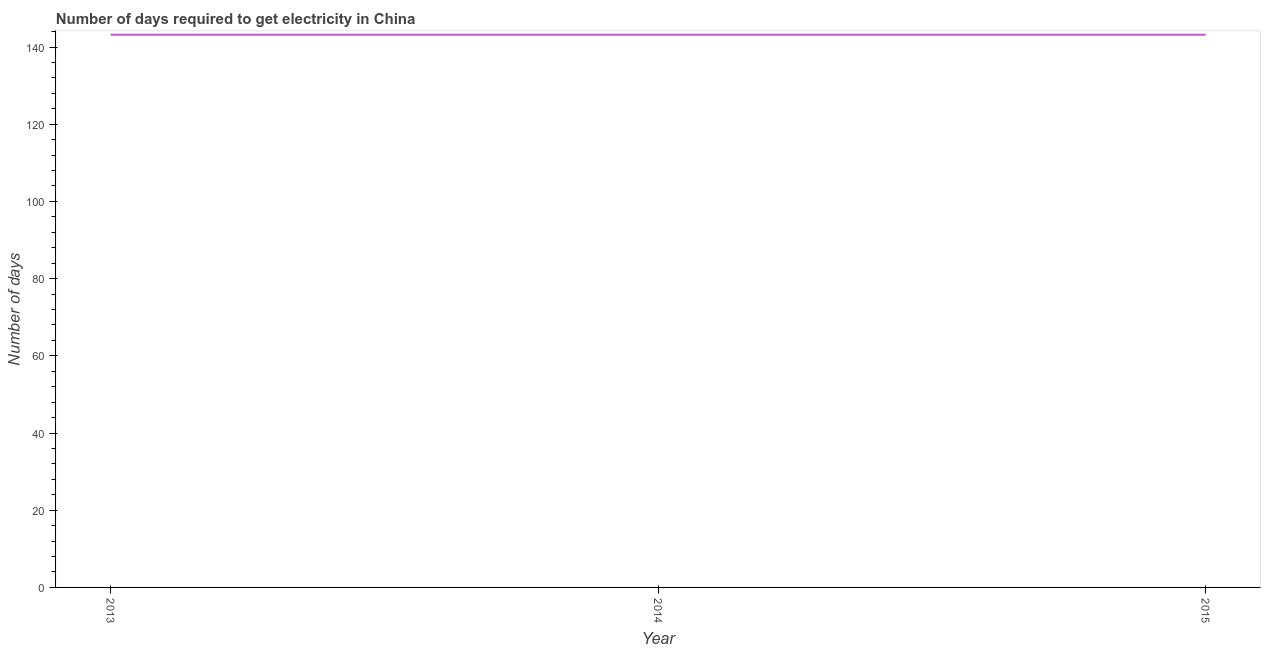What is the time to get electricity in 2015?
Your answer should be very brief. 143.2. Across all years, what is the maximum time to get electricity?
Give a very brief answer. 143.2. Across all years, what is the minimum time to get electricity?
Provide a succinct answer. 143.2. In which year was the time to get electricity maximum?
Offer a very short reply. 2013. In which year was the time to get electricity minimum?
Provide a succinct answer. 2013. What is the sum of the time to get electricity?
Ensure brevity in your answer.  429.6. What is the average time to get electricity per year?
Give a very brief answer. 143.2. What is the median time to get electricity?
Offer a very short reply. 143.2. In how many years, is the time to get electricity greater than 80 ?
Provide a succinct answer. 3. Do a majority of the years between 2015 and 2014 (inclusive) have time to get electricity greater than 36 ?
Your answer should be very brief. No. What is the ratio of the time to get electricity in 2013 to that in 2015?
Offer a very short reply. 1. What is the difference between the highest and the lowest time to get electricity?
Your response must be concise. 0. In how many years, is the time to get electricity greater than the average time to get electricity taken over all years?
Ensure brevity in your answer.  0. How many years are there in the graph?
Your response must be concise. 3. What is the difference between two consecutive major ticks on the Y-axis?
Offer a very short reply. 20. What is the title of the graph?
Your response must be concise. Number of days required to get electricity in China. What is the label or title of the X-axis?
Your response must be concise. Year. What is the label or title of the Y-axis?
Offer a terse response. Number of days. What is the Number of days in 2013?
Give a very brief answer. 143.2. What is the Number of days in 2014?
Provide a succinct answer. 143.2. What is the Number of days in 2015?
Make the answer very short. 143.2. What is the difference between the Number of days in 2013 and 2015?
Make the answer very short. 0. What is the difference between the Number of days in 2014 and 2015?
Your answer should be compact. 0. What is the ratio of the Number of days in 2013 to that in 2014?
Offer a very short reply. 1. What is the ratio of the Number of days in 2013 to that in 2015?
Offer a terse response. 1. 